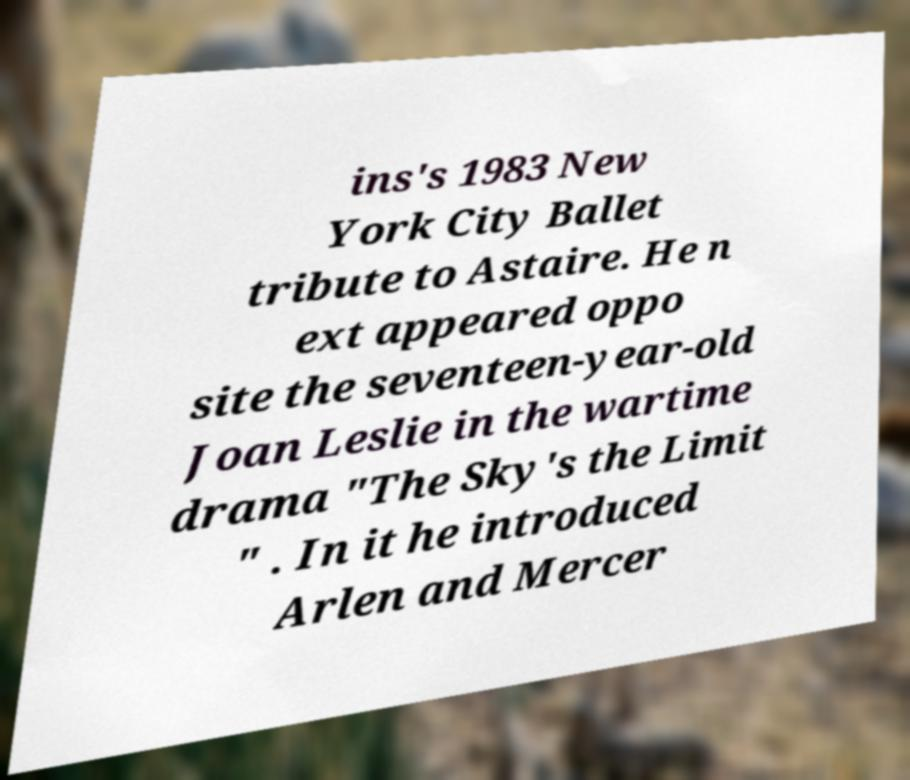Can you accurately transcribe the text from the provided image for me? ins's 1983 New York City Ballet tribute to Astaire. He n ext appeared oppo site the seventeen-year-old Joan Leslie in the wartime drama "The Sky's the Limit " . In it he introduced Arlen and Mercer 